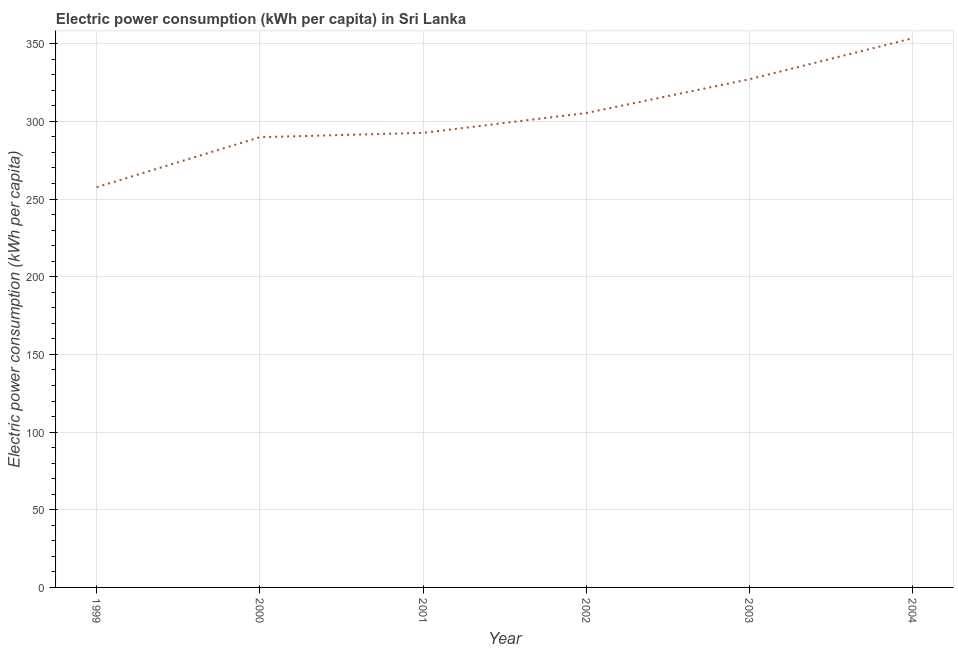What is the electric power consumption in 2002?
Your answer should be compact. 305.37. Across all years, what is the maximum electric power consumption?
Offer a terse response. 353.49. Across all years, what is the minimum electric power consumption?
Keep it short and to the point. 257.61. In which year was the electric power consumption maximum?
Offer a very short reply. 2004. What is the sum of the electric power consumption?
Provide a short and direct response. 1826.01. What is the difference between the electric power consumption in 1999 and 2002?
Your answer should be very brief. -47.77. What is the average electric power consumption per year?
Your answer should be compact. 304.33. What is the median electric power consumption?
Keep it short and to the point. 298.99. What is the ratio of the electric power consumption in 1999 to that in 2004?
Offer a very short reply. 0.73. What is the difference between the highest and the second highest electric power consumption?
Ensure brevity in your answer.  26.36. What is the difference between the highest and the lowest electric power consumption?
Your answer should be very brief. 95.88. In how many years, is the electric power consumption greater than the average electric power consumption taken over all years?
Offer a terse response. 3. How many lines are there?
Keep it short and to the point. 1. How many years are there in the graph?
Offer a terse response. 6. What is the difference between two consecutive major ticks on the Y-axis?
Offer a terse response. 50. Does the graph contain any zero values?
Give a very brief answer. No. Does the graph contain grids?
Your answer should be compact. Yes. What is the title of the graph?
Your answer should be very brief. Electric power consumption (kWh per capita) in Sri Lanka. What is the label or title of the Y-axis?
Give a very brief answer. Electric power consumption (kWh per capita). What is the Electric power consumption (kWh per capita) of 1999?
Your answer should be very brief. 257.61. What is the Electric power consumption (kWh per capita) in 2000?
Offer a very short reply. 289.81. What is the Electric power consumption (kWh per capita) in 2001?
Offer a very short reply. 292.6. What is the Electric power consumption (kWh per capita) of 2002?
Ensure brevity in your answer.  305.37. What is the Electric power consumption (kWh per capita) in 2003?
Provide a short and direct response. 327.13. What is the Electric power consumption (kWh per capita) in 2004?
Make the answer very short. 353.49. What is the difference between the Electric power consumption (kWh per capita) in 1999 and 2000?
Provide a succinct answer. -32.2. What is the difference between the Electric power consumption (kWh per capita) in 1999 and 2001?
Ensure brevity in your answer.  -34.99. What is the difference between the Electric power consumption (kWh per capita) in 1999 and 2002?
Offer a very short reply. -47.77. What is the difference between the Electric power consumption (kWh per capita) in 1999 and 2003?
Your response must be concise. -69.52. What is the difference between the Electric power consumption (kWh per capita) in 1999 and 2004?
Make the answer very short. -95.88. What is the difference between the Electric power consumption (kWh per capita) in 2000 and 2001?
Your answer should be compact. -2.79. What is the difference between the Electric power consumption (kWh per capita) in 2000 and 2002?
Your answer should be very brief. -15.56. What is the difference between the Electric power consumption (kWh per capita) in 2000 and 2003?
Provide a succinct answer. -37.31. What is the difference between the Electric power consumption (kWh per capita) in 2000 and 2004?
Make the answer very short. -63.67. What is the difference between the Electric power consumption (kWh per capita) in 2001 and 2002?
Keep it short and to the point. -12.78. What is the difference between the Electric power consumption (kWh per capita) in 2001 and 2003?
Ensure brevity in your answer.  -34.53. What is the difference between the Electric power consumption (kWh per capita) in 2001 and 2004?
Give a very brief answer. -60.89. What is the difference between the Electric power consumption (kWh per capita) in 2002 and 2003?
Your answer should be compact. -21.75. What is the difference between the Electric power consumption (kWh per capita) in 2002 and 2004?
Your answer should be compact. -48.11. What is the difference between the Electric power consumption (kWh per capita) in 2003 and 2004?
Ensure brevity in your answer.  -26.36. What is the ratio of the Electric power consumption (kWh per capita) in 1999 to that in 2000?
Your answer should be very brief. 0.89. What is the ratio of the Electric power consumption (kWh per capita) in 1999 to that in 2002?
Offer a very short reply. 0.84. What is the ratio of the Electric power consumption (kWh per capita) in 1999 to that in 2003?
Your response must be concise. 0.79. What is the ratio of the Electric power consumption (kWh per capita) in 1999 to that in 2004?
Provide a short and direct response. 0.73. What is the ratio of the Electric power consumption (kWh per capita) in 2000 to that in 2002?
Give a very brief answer. 0.95. What is the ratio of the Electric power consumption (kWh per capita) in 2000 to that in 2003?
Offer a terse response. 0.89. What is the ratio of the Electric power consumption (kWh per capita) in 2000 to that in 2004?
Your answer should be very brief. 0.82. What is the ratio of the Electric power consumption (kWh per capita) in 2001 to that in 2002?
Your response must be concise. 0.96. What is the ratio of the Electric power consumption (kWh per capita) in 2001 to that in 2003?
Offer a very short reply. 0.89. What is the ratio of the Electric power consumption (kWh per capita) in 2001 to that in 2004?
Your answer should be compact. 0.83. What is the ratio of the Electric power consumption (kWh per capita) in 2002 to that in 2003?
Make the answer very short. 0.93. What is the ratio of the Electric power consumption (kWh per capita) in 2002 to that in 2004?
Your answer should be compact. 0.86. What is the ratio of the Electric power consumption (kWh per capita) in 2003 to that in 2004?
Provide a short and direct response. 0.93. 